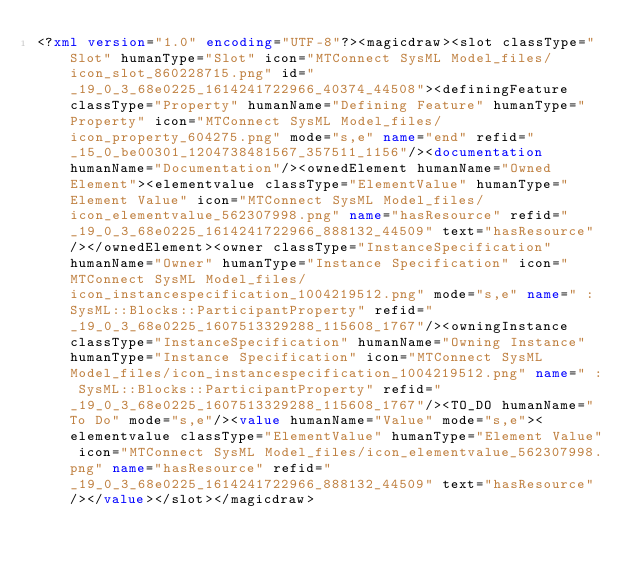<code> <loc_0><loc_0><loc_500><loc_500><_XML_><?xml version="1.0" encoding="UTF-8"?><magicdraw><slot classType="Slot" humanType="Slot" icon="MTConnect SysML Model_files/icon_slot_860228715.png" id="_19_0_3_68e0225_1614241722966_40374_44508"><definingFeature classType="Property" humanName="Defining Feature" humanType="Property" icon="MTConnect SysML Model_files/icon_property_604275.png" mode="s,e" name="end" refid="_15_0_be00301_1204738481567_357511_1156"/><documentation humanName="Documentation"/><ownedElement humanName="Owned Element"><elementvalue classType="ElementValue" humanType="Element Value" icon="MTConnect SysML Model_files/icon_elementvalue_562307998.png" name="hasResource" refid="_19_0_3_68e0225_1614241722966_888132_44509" text="hasResource"/></ownedElement><owner classType="InstanceSpecification" humanName="Owner" humanType="Instance Specification" icon="MTConnect SysML Model_files/icon_instancespecification_1004219512.png" mode="s,e" name=" : SysML::Blocks::ParticipantProperty" refid="_19_0_3_68e0225_1607513329288_115608_1767"/><owningInstance classType="InstanceSpecification" humanName="Owning Instance" humanType="Instance Specification" icon="MTConnect SysML Model_files/icon_instancespecification_1004219512.png" name=" : SysML::Blocks::ParticipantProperty" refid="_19_0_3_68e0225_1607513329288_115608_1767"/><TO_DO humanName="To Do" mode="s,e"/><value humanName="Value" mode="s,e"><elementvalue classType="ElementValue" humanType="Element Value" icon="MTConnect SysML Model_files/icon_elementvalue_562307998.png" name="hasResource" refid="_19_0_3_68e0225_1614241722966_888132_44509" text="hasResource"/></value></slot></magicdraw></code> 